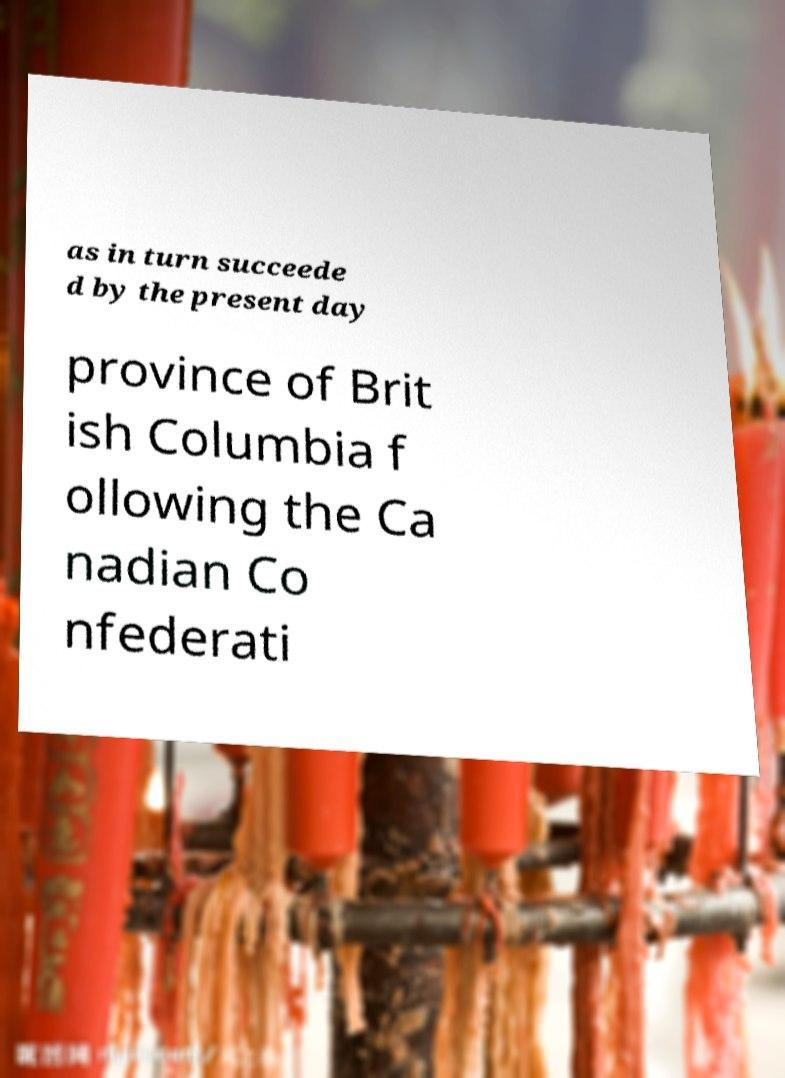I need the written content from this picture converted into text. Can you do that? as in turn succeede d by the present day province of Brit ish Columbia f ollowing the Ca nadian Co nfederati 